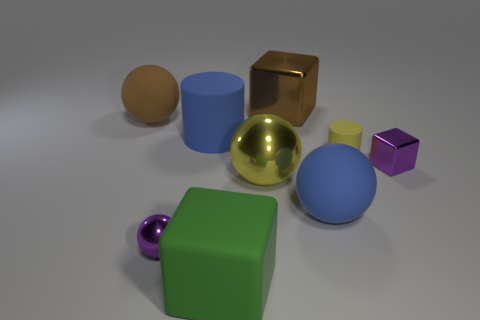Are there more big blue things than tiny balls?
Your response must be concise. Yes. What material is the large thing that is the same shape as the tiny rubber thing?
Make the answer very short. Rubber. Is the big blue cylinder made of the same material as the brown block?
Ensure brevity in your answer.  No. Is the number of cubes that are in front of the small rubber cylinder greater than the number of shiny blocks?
Your answer should be compact. No. There is a thing behind the big rubber sphere behind the cylinder that is on the right side of the big green block; what is it made of?
Ensure brevity in your answer.  Metal. What number of things are either purple objects or tiny objects behind the big yellow metal sphere?
Your answer should be compact. 3. Do the small shiny thing that is to the right of the large green matte cube and the large rubber cylinder have the same color?
Your response must be concise. No. Is the number of big rubber cubes behind the yellow shiny sphere greater than the number of big yellow metal balls behind the brown metallic cube?
Your response must be concise. No. Are there any other things that are the same color as the tiny metallic block?
Ensure brevity in your answer.  Yes. How many things are big brown balls or small yellow matte cylinders?
Your answer should be compact. 2. 